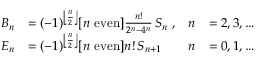Convert formula to latex. <formula><loc_0><loc_0><loc_500><loc_500>{ \begin{array} { r l r l } { B _ { n } } & { = ( - 1 ) ^ { \left \lfloor { \frac { n } { 2 } } \right \rfloor } [ n { e v e n } ] { \frac { n ! } { 2 ^ { n } - 4 ^ { n } } } \, S _ { n } \ , } & { n } & { = 2 , 3 , \dots } \\ { E _ { n } } & { = ( - 1 ) ^ { \left \lfloor { \frac { n } { 2 } } \right \rfloor } [ n { e v e n } ] n ! \, S _ { n + 1 } } & { n } & { = 0 , 1 , \dots } \end{array} }</formula> 